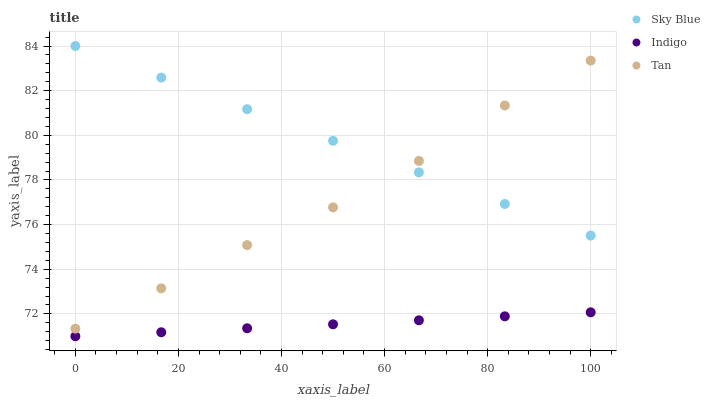Does Indigo have the minimum area under the curve?
Answer yes or no. Yes. Does Sky Blue have the maximum area under the curve?
Answer yes or no. Yes. Does Tan have the minimum area under the curve?
Answer yes or no. No. Does Tan have the maximum area under the curve?
Answer yes or no. No. Is Indigo the smoothest?
Answer yes or no. Yes. Is Tan the roughest?
Answer yes or no. Yes. Is Tan the smoothest?
Answer yes or no. No. Is Indigo the roughest?
Answer yes or no. No. Does Indigo have the lowest value?
Answer yes or no. Yes. Does Tan have the lowest value?
Answer yes or no. No. Does Sky Blue have the highest value?
Answer yes or no. Yes. Does Tan have the highest value?
Answer yes or no. No. Is Indigo less than Sky Blue?
Answer yes or no. Yes. Is Sky Blue greater than Indigo?
Answer yes or no. Yes. Does Sky Blue intersect Tan?
Answer yes or no. Yes. Is Sky Blue less than Tan?
Answer yes or no. No. Is Sky Blue greater than Tan?
Answer yes or no. No. Does Indigo intersect Sky Blue?
Answer yes or no. No. 